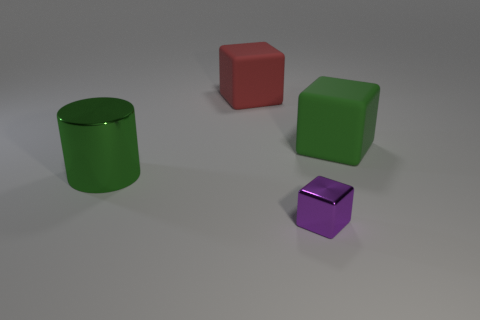There is a big block to the right of the metal object in front of the metal cylinder; what is it made of?
Ensure brevity in your answer.  Rubber. Is the material of the block in front of the large green metal cylinder the same as the red thing?
Give a very brief answer. No. There is a cube in front of the large cylinder; what is its size?
Offer a terse response. Small. There is a large green object behind the large shiny cylinder; are there any large things that are behind it?
Offer a very short reply. Yes. There is a matte cube in front of the big red matte object; does it have the same color as the metallic thing behind the purple cube?
Your answer should be very brief. Yes. What is the color of the cylinder?
Offer a very short reply. Green. Is there any other thing that is the same color as the large metallic object?
Provide a succinct answer. Yes. What color is the thing that is in front of the large red object and on the left side of the purple thing?
Your answer should be compact. Green. There is a green thing that is on the right side of the cylinder; is it the same size as the metal cylinder?
Give a very brief answer. Yes. Are there more metal cylinders behind the tiny purple thing than small brown metal things?
Provide a succinct answer. Yes. 